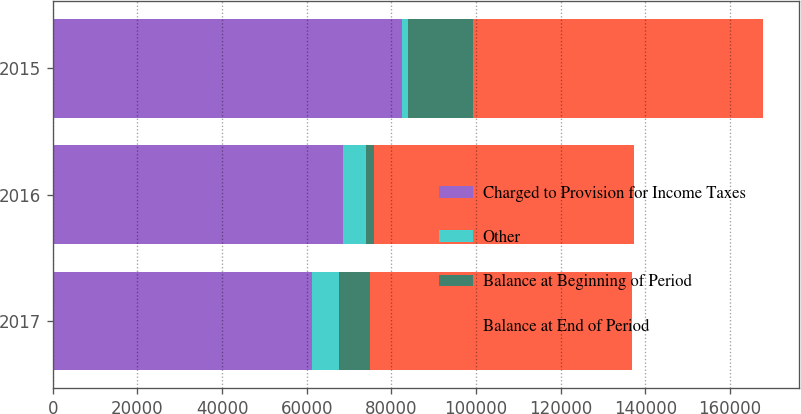Convert chart to OTSL. <chart><loc_0><loc_0><loc_500><loc_500><stacked_bar_chart><ecel><fcel>2017<fcel>2016<fcel>2015<nl><fcel>Charged to Provision for Income Taxes<fcel>61225<fcel>68595<fcel>82550<nl><fcel>Other<fcel>6363<fcel>5473<fcel>1363<nl><fcel>Balance at Beginning of Period<fcel>7236<fcel>1897<fcel>15318<nl><fcel>Balance at End of Period<fcel>62098<fcel>61225<fcel>68595<nl></chart> 